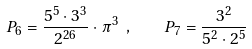Convert formula to latex. <formula><loc_0><loc_0><loc_500><loc_500>P _ { 6 } = \frac { 5 ^ { 5 } \cdot 3 ^ { 3 } } { 2 ^ { 2 6 } } \cdot \pi ^ { 3 } \ , \quad P _ { 7 } = \frac { 3 ^ { 2 } } { 5 ^ { 2 } \cdot 2 ^ { 5 } }</formula> 